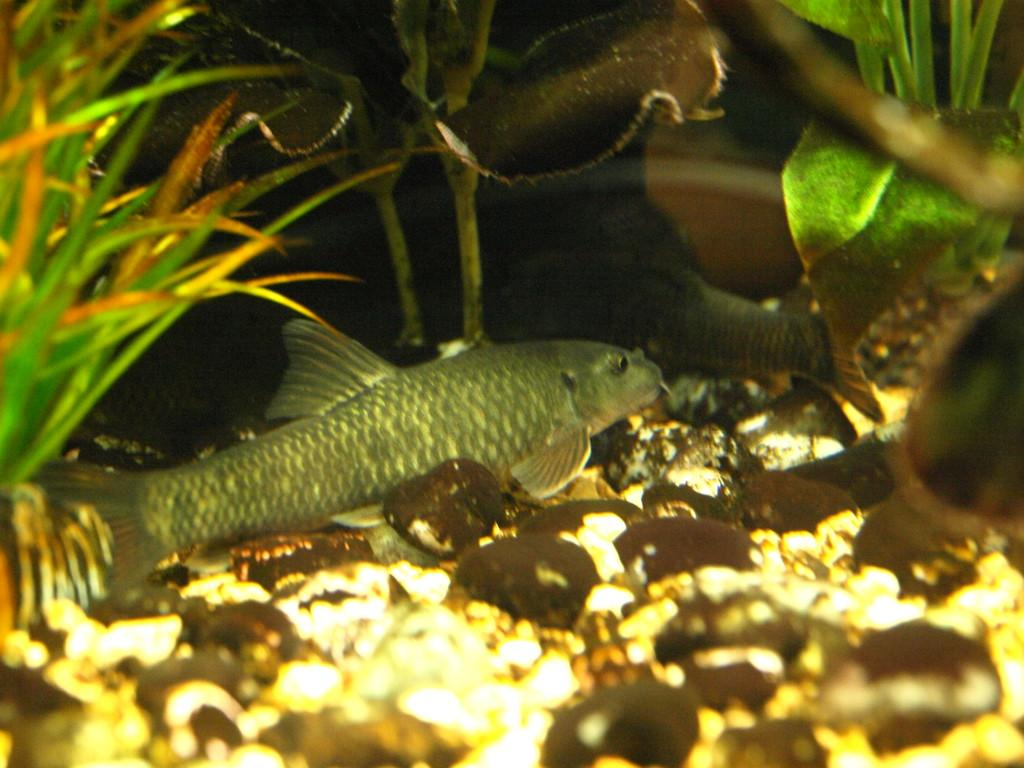What is the main subject of the image? There is a fish on a stone in the image. What can be seen in the water? There are plants and shells in the water. What type of vegetation is visible in the image? There is grass visible in the image. What type of shirt is the fish wearing in the image? There is no shirt present in the image, as fish do not wear clothing. 